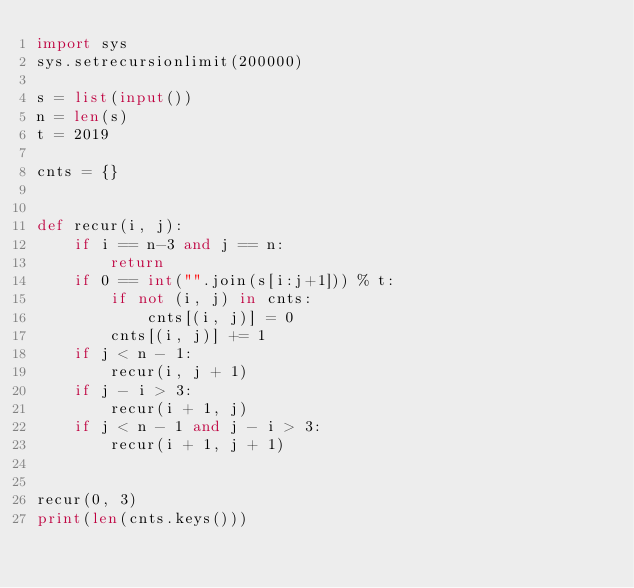Convert code to text. <code><loc_0><loc_0><loc_500><loc_500><_Python_>import sys
sys.setrecursionlimit(200000)

s = list(input())
n = len(s)
t = 2019

cnts = {}


def recur(i, j):
    if i == n-3 and j == n:
        return
    if 0 == int("".join(s[i:j+1])) % t:
        if not (i, j) in cnts:
            cnts[(i, j)] = 0
        cnts[(i, j)] += 1
    if j < n - 1:
        recur(i, j + 1)
    if j - i > 3:
        recur(i + 1, j)
    if j < n - 1 and j - i > 3:
        recur(i + 1, j + 1)


recur(0, 3)
print(len(cnts.keys()))
</code> 